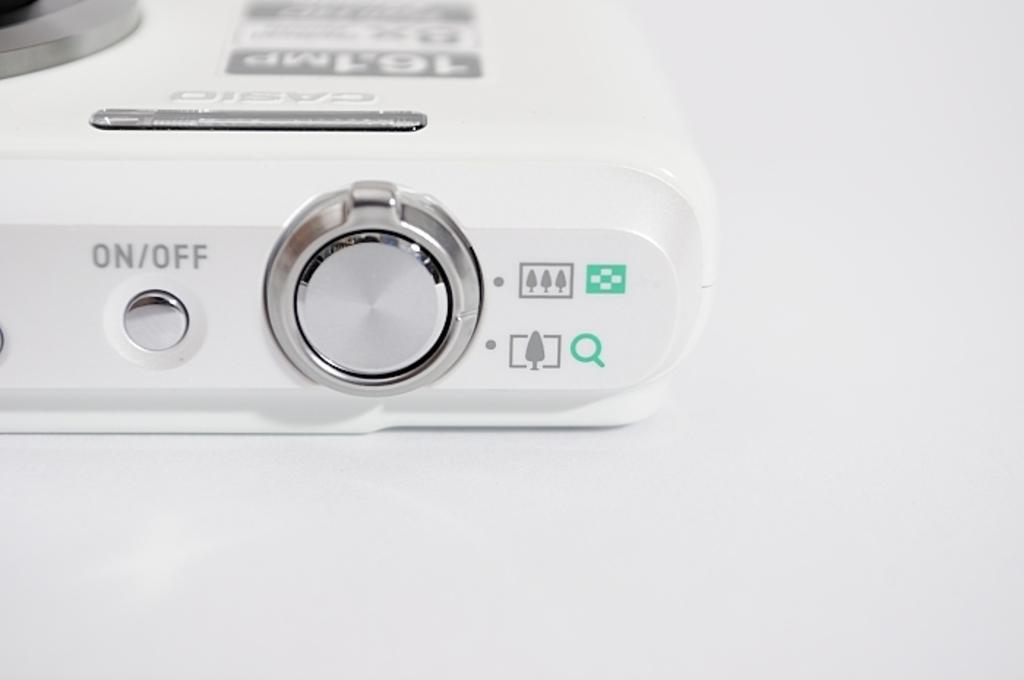<image>
Write a terse but informative summary of the picture. A small silver button is labeled as on/off. 